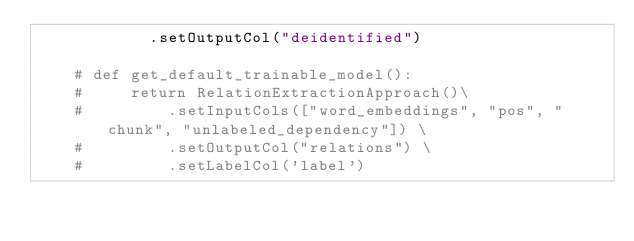Convert code to text. <code><loc_0><loc_0><loc_500><loc_500><_Python_>            .setOutputCol("deidentified")

    # def get_default_trainable_model():
    #     return RelationExtractionApproach()\
    #         .setInputCols(["word_embeddings", "pos", "chunk", "unlabeled_dependency"]) \
    #         .setOutputCol("relations") \
    #         .setLabelCol('label')
</code> 